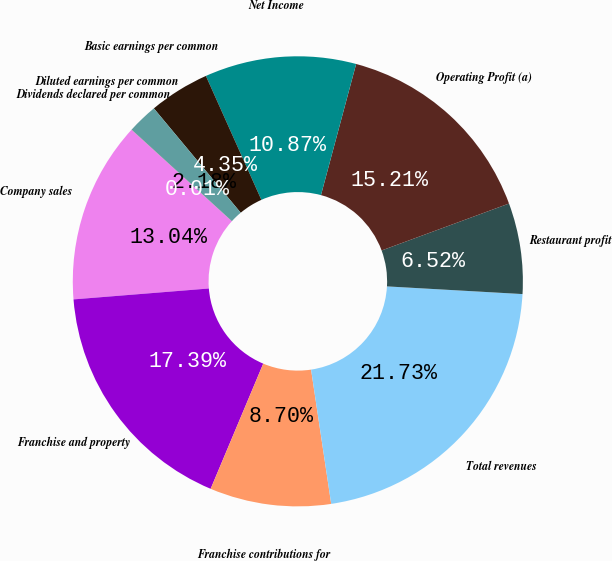Convert chart to OTSL. <chart><loc_0><loc_0><loc_500><loc_500><pie_chart><fcel>Company sales<fcel>Franchise and property<fcel>Franchise contributions for<fcel>Total revenues<fcel>Restaurant profit<fcel>Operating Profit (a)<fcel>Net Income<fcel>Basic earnings per common<fcel>Diluted earnings per common<fcel>Dividends declared per common<nl><fcel>13.04%<fcel>17.39%<fcel>8.7%<fcel>21.73%<fcel>6.52%<fcel>15.21%<fcel>10.87%<fcel>4.35%<fcel>2.18%<fcel>0.01%<nl></chart> 